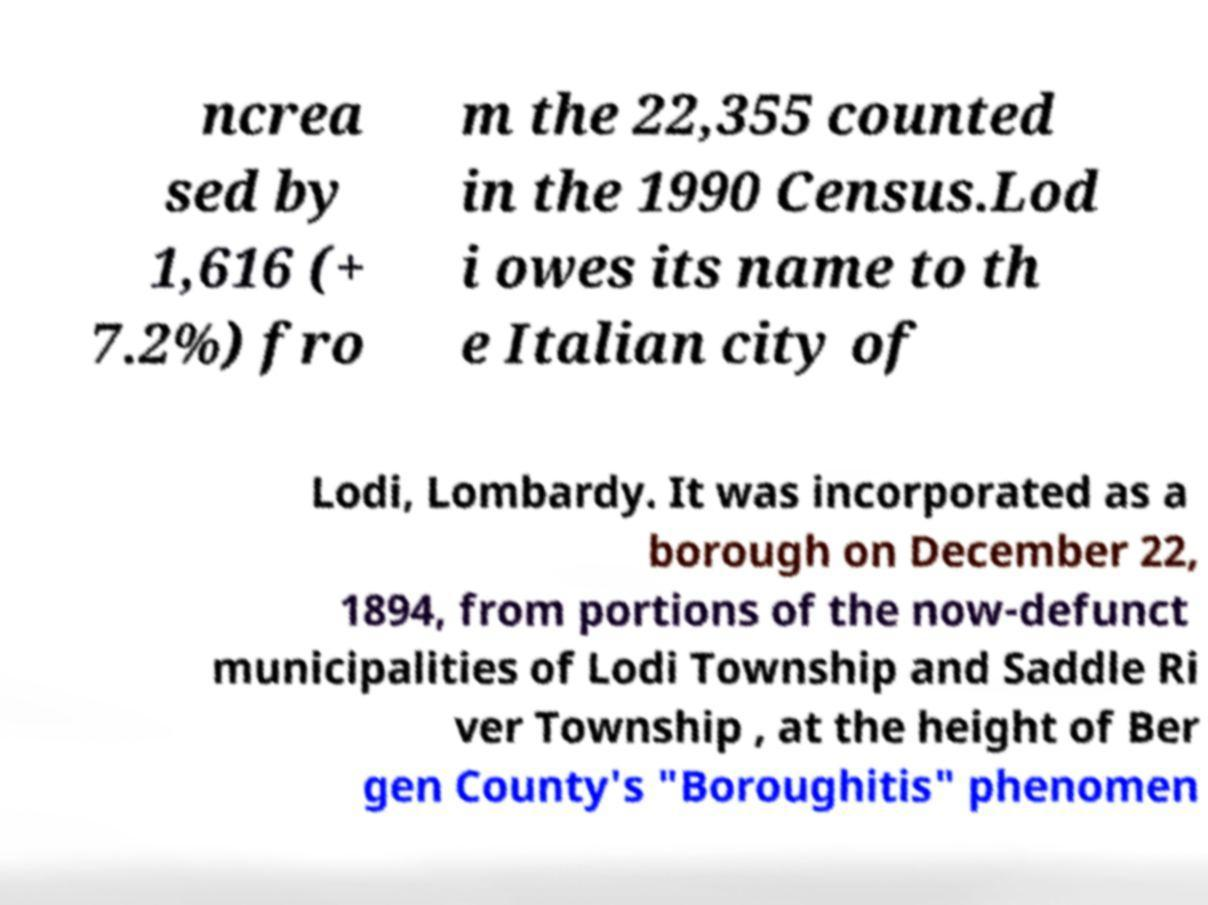There's text embedded in this image that I need extracted. Can you transcribe it verbatim? ncrea sed by 1,616 (+ 7.2%) fro m the 22,355 counted in the 1990 Census.Lod i owes its name to th e Italian city of Lodi, Lombardy. It was incorporated as a borough on December 22, 1894, from portions of the now-defunct municipalities of Lodi Township and Saddle Ri ver Township , at the height of Ber gen County's "Boroughitis" phenomen 